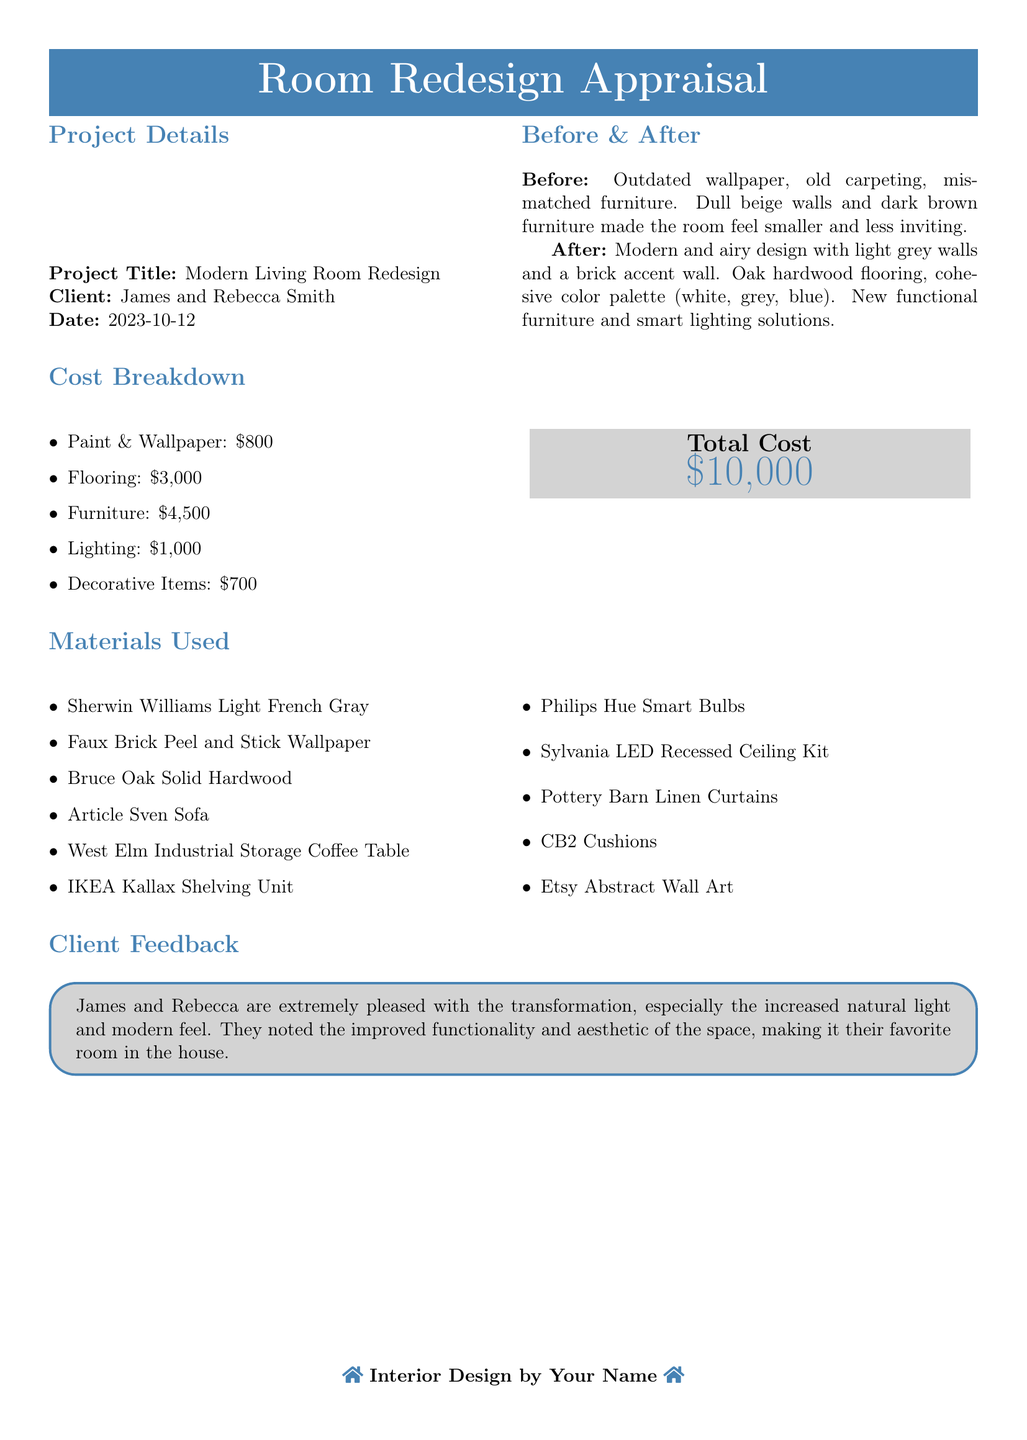What is the project title? The project title is stated clearly at the beginning of the document in the project details section.
Answer: Modern Living Room Redesign Who are the clients? The clients are mentioned in the project details section under the title and date.
Answer: James and Rebecca Smith What was the total cost of the redesign? The total cost is provided in the cost breakdown section, summarized at the end.
Answer: $10,000 What type of flooring was used? The materials used are listed in the materials section of the document.
Answer: Bruce Oak Solid Hardwood What is one item used for lighting? The document includes a list of materials that covers different types of items used for the redesign, specifically for lighting.
Answer: Philips Hue Smart Bulbs What did the clients appreciate about the transformation? The client feedback section provides insights into the clients' satisfaction with the redesign.
Answer: Increased natural light How many items are listed under materials used? The total number of items is counted from the materials section where they are clearly listed.
Answer: 11 What kind of wallpaper was used? The type of wallpaper is specified in the materials section of the document.
Answer: Faux Brick Peel and Stick Wallpaper What date was the appraisal completed? The date can be found in the project details section.
Answer: 2023-10-12 